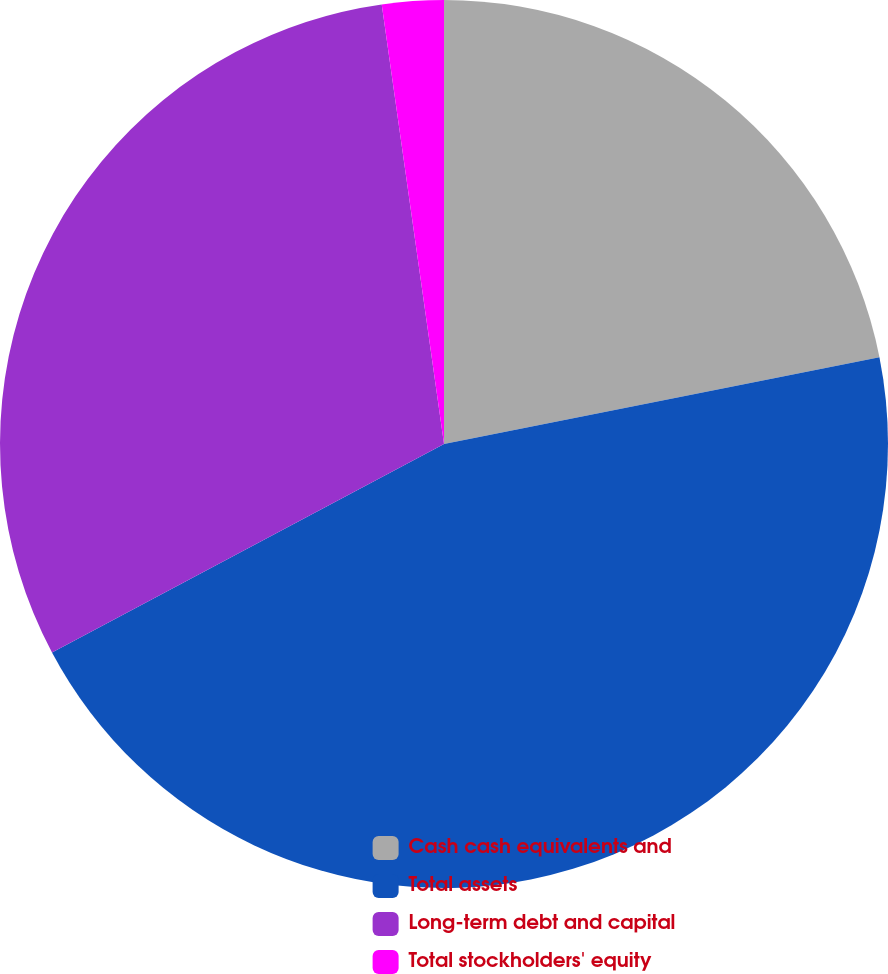<chart> <loc_0><loc_0><loc_500><loc_500><pie_chart><fcel>Cash cash equivalents and<fcel>Total assets<fcel>Long-term debt and capital<fcel>Total stockholders' equity<nl><fcel>21.87%<fcel>45.35%<fcel>30.54%<fcel>2.24%<nl></chart> 